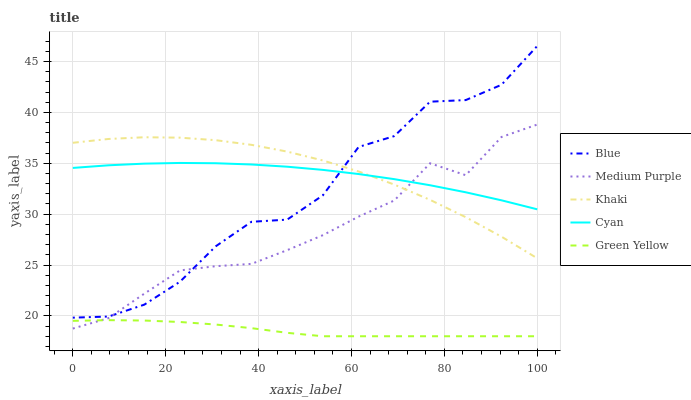Does Green Yellow have the minimum area under the curve?
Answer yes or no. Yes. Does Khaki have the maximum area under the curve?
Answer yes or no. Yes. Does Medium Purple have the minimum area under the curve?
Answer yes or no. No. Does Medium Purple have the maximum area under the curve?
Answer yes or no. No. Is Green Yellow the smoothest?
Answer yes or no. Yes. Is Blue the roughest?
Answer yes or no. Yes. Is Medium Purple the smoothest?
Answer yes or no. No. Is Medium Purple the roughest?
Answer yes or no. No. Does Green Yellow have the lowest value?
Answer yes or no. Yes. Does Medium Purple have the lowest value?
Answer yes or no. No. Does Blue have the highest value?
Answer yes or no. Yes. Does Medium Purple have the highest value?
Answer yes or no. No. Is Green Yellow less than Cyan?
Answer yes or no. Yes. Is Khaki greater than Green Yellow?
Answer yes or no. Yes. Does Khaki intersect Cyan?
Answer yes or no. Yes. Is Khaki less than Cyan?
Answer yes or no. No. Is Khaki greater than Cyan?
Answer yes or no. No. Does Green Yellow intersect Cyan?
Answer yes or no. No. 